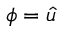Convert formula to latex. <formula><loc_0><loc_0><loc_500><loc_500>\phi = { \hat { u } }</formula> 